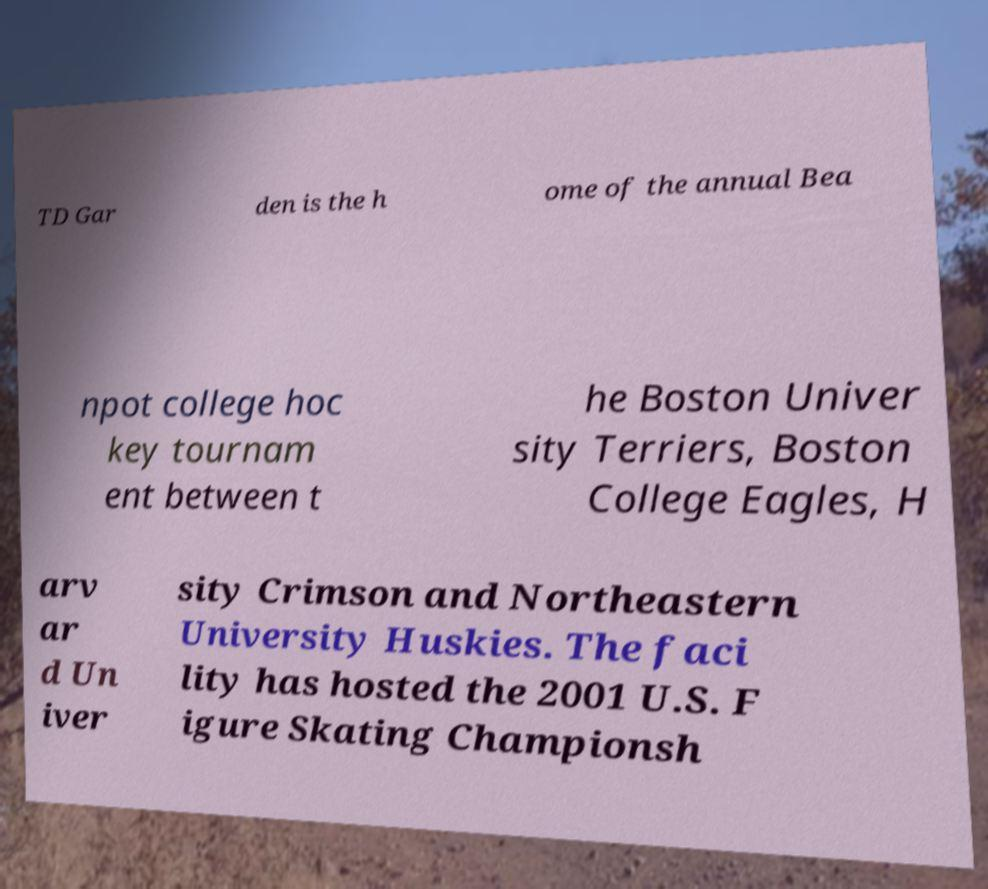Could you extract and type out the text from this image? TD Gar den is the h ome of the annual Bea npot college hoc key tournam ent between t he Boston Univer sity Terriers, Boston College Eagles, H arv ar d Un iver sity Crimson and Northeastern University Huskies. The faci lity has hosted the 2001 U.S. F igure Skating Championsh 